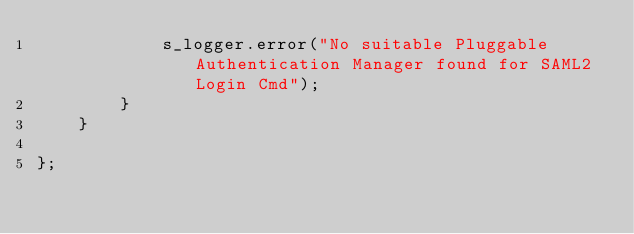Convert code to text. <code><loc_0><loc_0><loc_500><loc_500><_Java_>            s_logger.error("No suitable Pluggable Authentication Manager found for SAML2 Login Cmd");
        }
    }

};</code> 